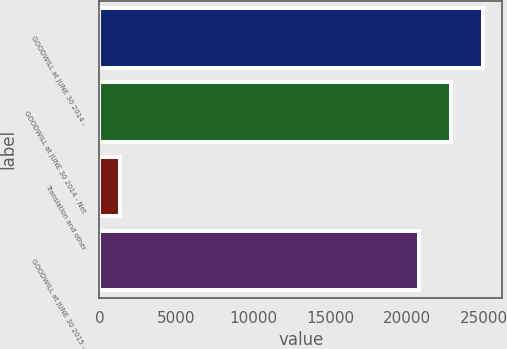<chart> <loc_0><loc_0><loc_500><loc_500><bar_chart><fcel>GOODWILL at JUNE 30 2014 -<fcel>GOODWILL at JUNE 30 2014 - Net<fcel>Translation and other<fcel>GOODWILL at JUNE 30 2015 -<nl><fcel>24932.4<fcel>22854.7<fcel>1320<fcel>20777<nl></chart> 